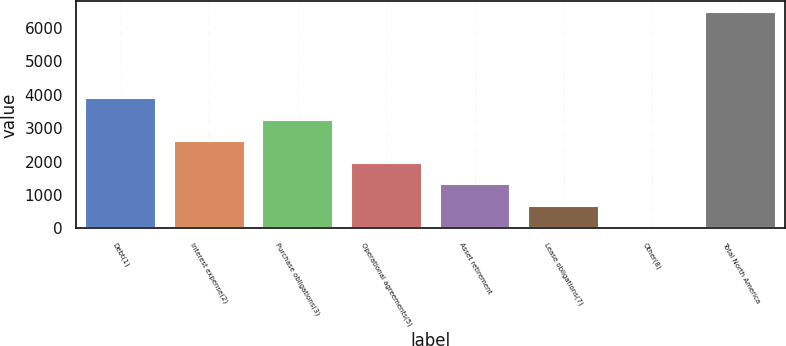Convert chart. <chart><loc_0><loc_0><loc_500><loc_500><bar_chart><fcel>Debt(1)<fcel>Interest expense(2)<fcel>Purchase obligations(3)<fcel>Operational agreements(5)<fcel>Asset retirement<fcel>Lease obligations(7)<fcel>Other(8)<fcel>Total North America<nl><fcel>3899<fcel>2611<fcel>3255<fcel>1967<fcel>1323<fcel>679<fcel>35<fcel>6475<nl></chart> 